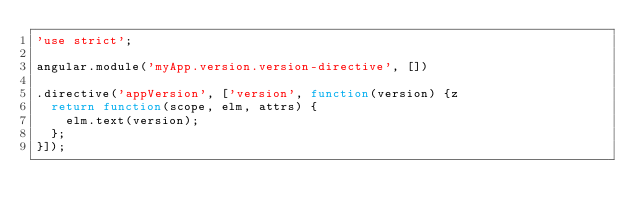Convert code to text. <code><loc_0><loc_0><loc_500><loc_500><_JavaScript_>'use strict';

angular.module('myApp.version.version-directive', [])

.directive('appVersion', ['version', function(version) {z
  return function(scope, elm, attrs) {
    elm.text(version);
  };
}]);
</code> 